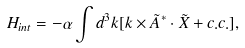Convert formula to latex. <formula><loc_0><loc_0><loc_500><loc_500>H _ { i n t } = - \alpha \int { d ^ { 3 } { k } } [ { k } \times \tilde { A } ^ { * } \cdot \tilde { X } + c . c . ] ,</formula> 